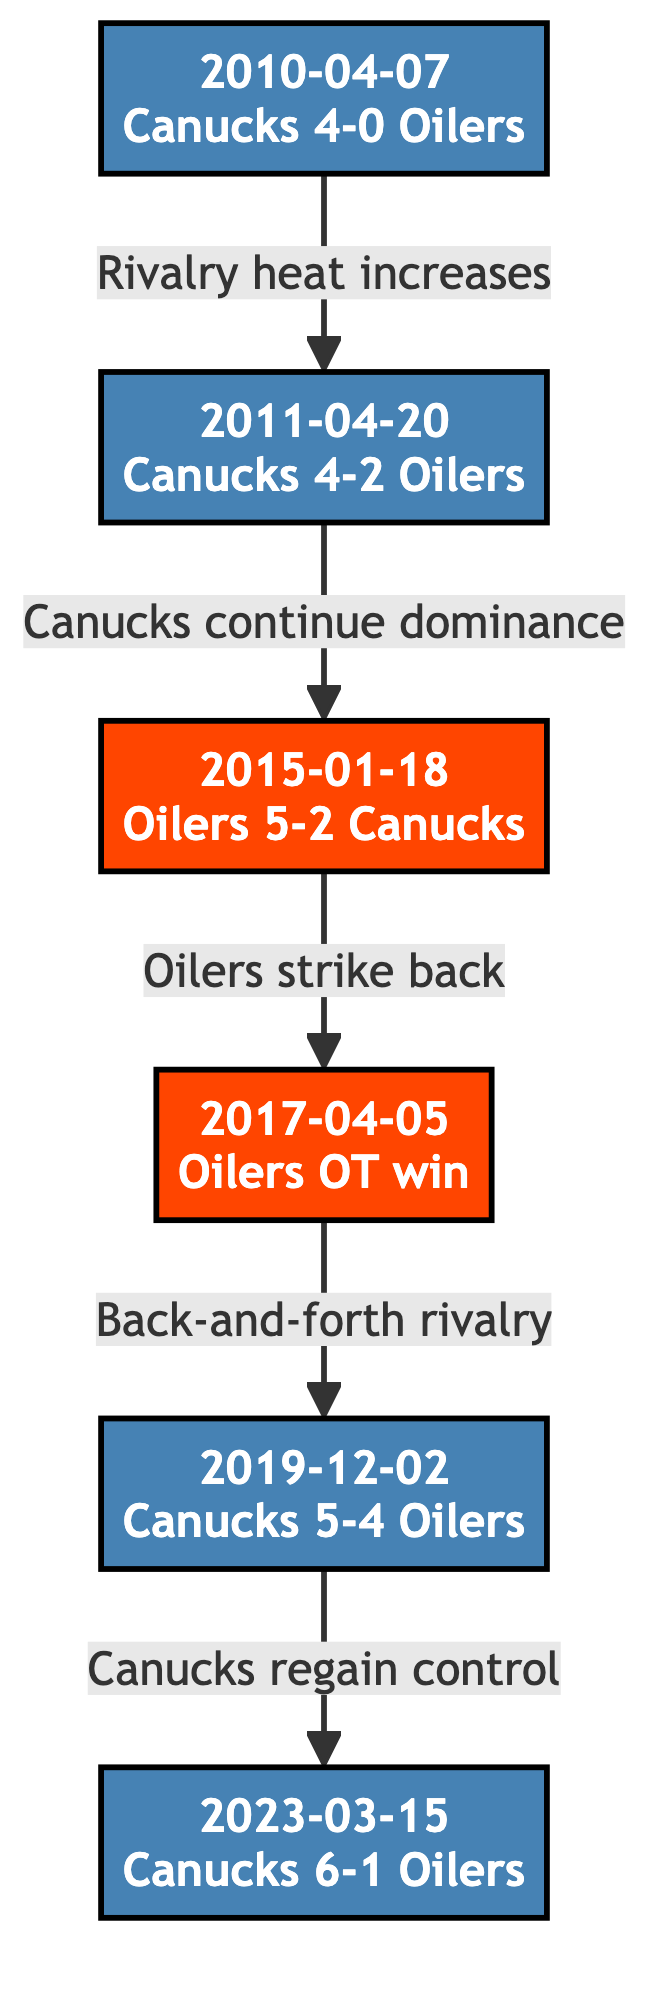What is the date of the Canucks' 4-0 shutout against the Oilers? The diagram indicates that the event Canucks vs Oilers with a 4-0 score occurred on April 7, 2010, as this is the label of that node.
Answer: 2010-04-07 What was the score of the 2011 Playoff Series Game 2? The label of the node for the 2011 Playoff Series Game 2 shows that the Canucks won with a score of 4-2, providing the exact score directly from the diagram.
Answer: 4-2 How many nodes are there in the diagram? By counting each of the events indicated in the diagram, we find a total of six distinct events (nodes) related to the rivalry over the specified timeline.
Answer: 6 What is the outcome of the game on January 18, 2015? The labeled node for that date shows that the Oilers won 5-2, thus indicating that the outcome of this game was a victory for the Oilers.
Answer: Oilers 5-2 Canucks Which game marked the return of Canucks' dominance? The edge labeled "Canucks regain control" leads to the node dated March 15, 2023, which means that the outcome of the game on this date marked the Canucks' return to dominance.
Answer: 2023-03-15 What relationship does the edge between 2011 Playoff Series Game 2 and Oilers vs Canucks describe? The edge between these two nodes is labeled "Canucks continue dominance," indicating that it describes the continuation of Canucks' superiority in the rivalry.
Answer: Canucks continue dominance How did Oilers fans react after the Canucks' loss on April 5, 2017? The description in the node for the April 5, 2017 game indicates that Oilers fans mockingly celebrated the Canucks' loss, providing an insight into the sentiment among Oilers supporters.
Answer: Mockingly celebrate Which two games are connected by the edge labeled "Back-and-forth rivalry"? The edge labeled "Back-and-forth rivalry" connects the April 5, 2017 game (Oilers OT win) to the December 2, 2019 game (Canucks 5-4 Oilers), indicating these games represent a competitive exchange in the rivalry.
Answer: 2017-04-05 and 2019-12-02 